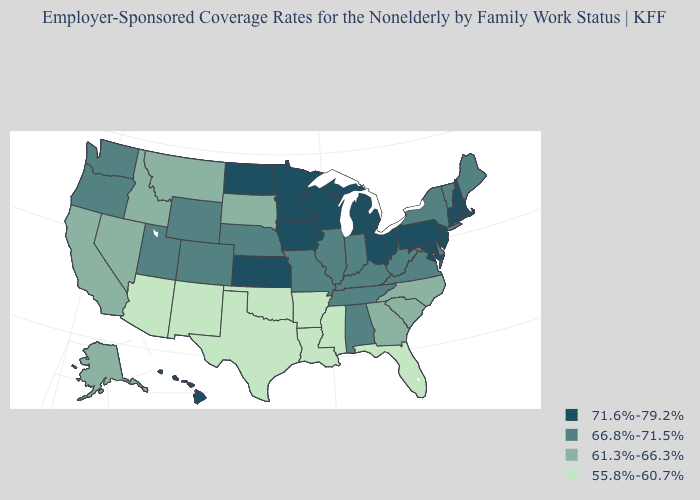Name the states that have a value in the range 61.3%-66.3%?
Concise answer only. Alaska, California, Georgia, Idaho, Montana, Nevada, North Carolina, South Carolina, South Dakota. Does Oklahoma have the lowest value in the USA?
Write a very short answer. Yes. Name the states that have a value in the range 66.8%-71.5%?
Keep it brief. Alabama, Colorado, Delaware, Illinois, Indiana, Kentucky, Maine, Missouri, Nebraska, New York, Oregon, Tennessee, Utah, Vermont, Virginia, Washington, West Virginia, Wyoming. Does Arizona have the lowest value in the West?
Be succinct. Yes. Among the states that border New Mexico , does Texas have the highest value?
Concise answer only. No. What is the value of Alabama?
Quick response, please. 66.8%-71.5%. Name the states that have a value in the range 71.6%-79.2%?
Keep it brief. Connecticut, Hawaii, Iowa, Kansas, Maryland, Massachusetts, Michigan, Minnesota, New Hampshire, New Jersey, North Dakota, Ohio, Pennsylvania, Rhode Island, Wisconsin. Name the states that have a value in the range 71.6%-79.2%?
Quick response, please. Connecticut, Hawaii, Iowa, Kansas, Maryland, Massachusetts, Michigan, Minnesota, New Hampshire, New Jersey, North Dakota, Ohio, Pennsylvania, Rhode Island, Wisconsin. Name the states that have a value in the range 61.3%-66.3%?
Short answer required. Alaska, California, Georgia, Idaho, Montana, Nevada, North Carolina, South Carolina, South Dakota. Does Kansas have the highest value in the USA?
Write a very short answer. Yes. Does New Jersey have the same value as Tennessee?
Quick response, please. No. Is the legend a continuous bar?
Short answer required. No. What is the lowest value in states that border Maryland?
Keep it brief. 66.8%-71.5%. Does Missouri have the same value as New York?
Keep it brief. Yes. Does Oklahoma have the highest value in the USA?
Short answer required. No. 